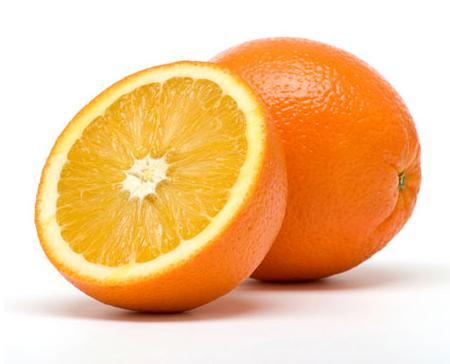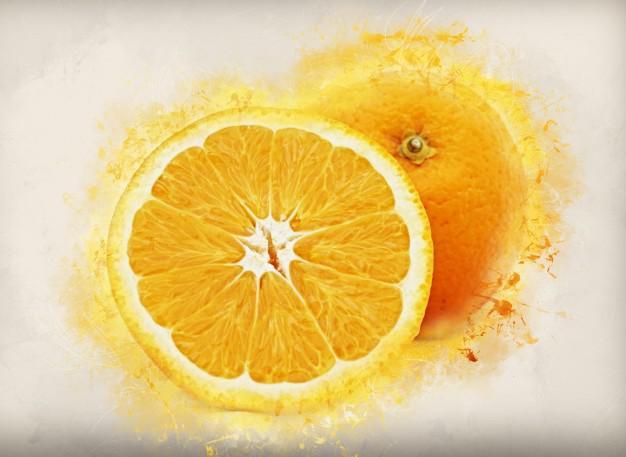The first image is the image on the left, the second image is the image on the right. Evaluate the accuracy of this statement regarding the images: "One image has exactly one and a half oranges.". Is it true? Answer yes or no. Yes. 